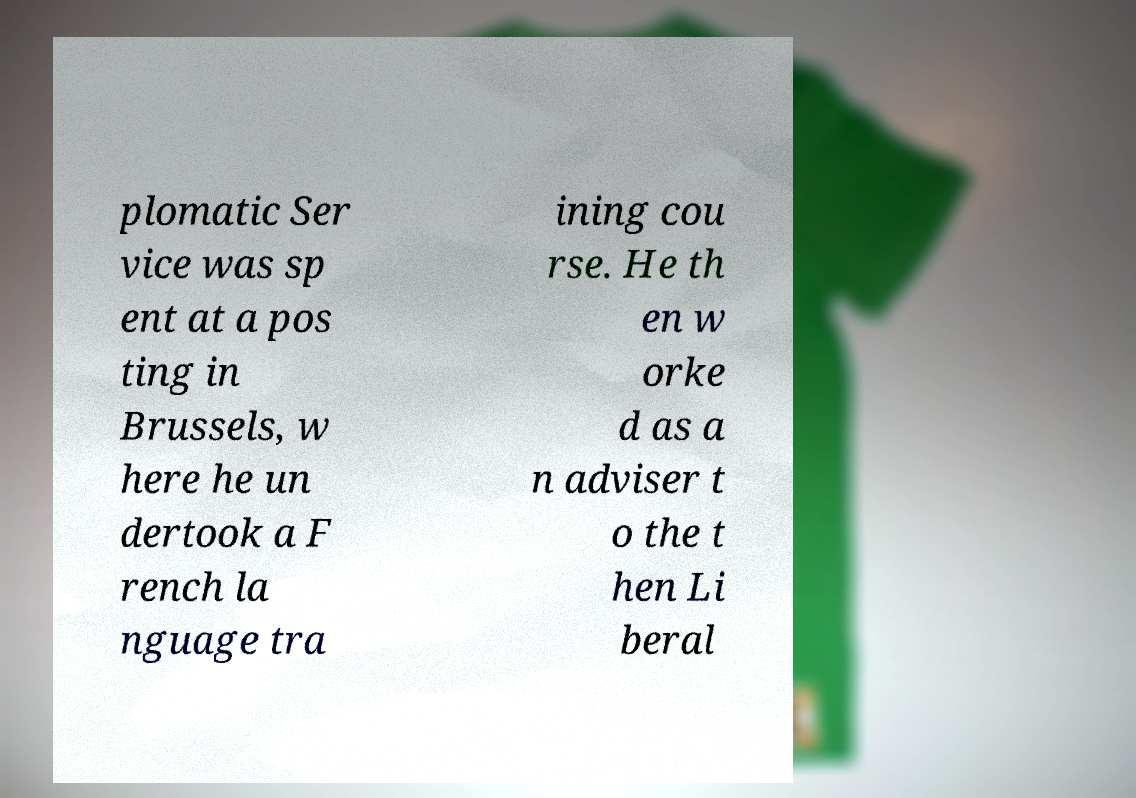I need the written content from this picture converted into text. Can you do that? plomatic Ser vice was sp ent at a pos ting in Brussels, w here he un dertook a F rench la nguage tra ining cou rse. He th en w orke d as a n adviser t o the t hen Li beral 